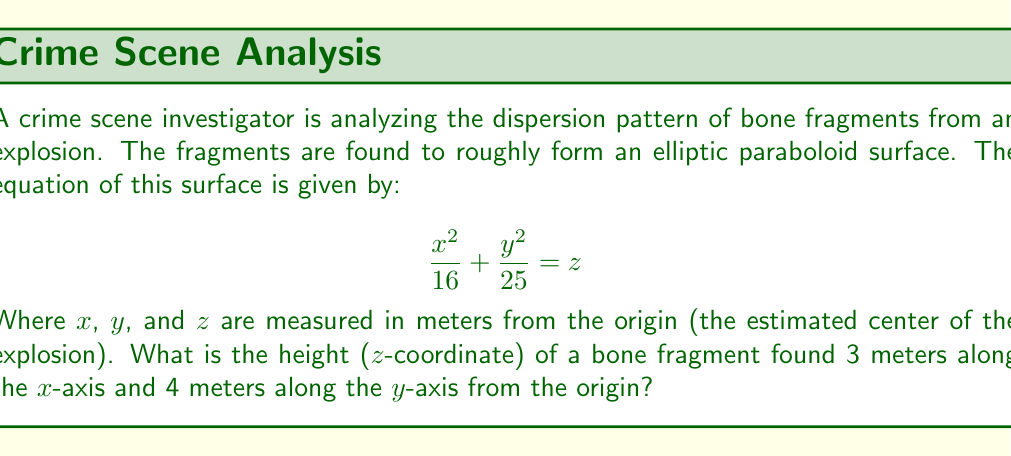Give your solution to this math problem. To solve this problem, we'll follow these steps:

1) The equation of the elliptic paraboloid is given as:

   $$\frac{x^2}{16} + \frac{y^2}{25} = z$$

2) We need to find z when x = 3 and y = 4. Let's substitute these values:

   $$\frac{3^2}{16} + \frac{4^2}{25} = z$$

3) Simplify the left side:

   $$\frac{9}{16} + \frac{16}{25} = z$$

4) Find a common denominator (80) to add these fractions:

   $$\frac{45}{80} + \frac{51}{80} = z$$

5) Add the fractions:

   $$\frac{96}{80} = z$$

6) Simplify the fraction:

   $$\frac{6}{5} = z$$

7) Convert to a decimal:

   $$1.2 = z$$

Therefore, the height (z-coordinate) of the bone fragment is 1.2 meters.
Answer: 1.2 meters 